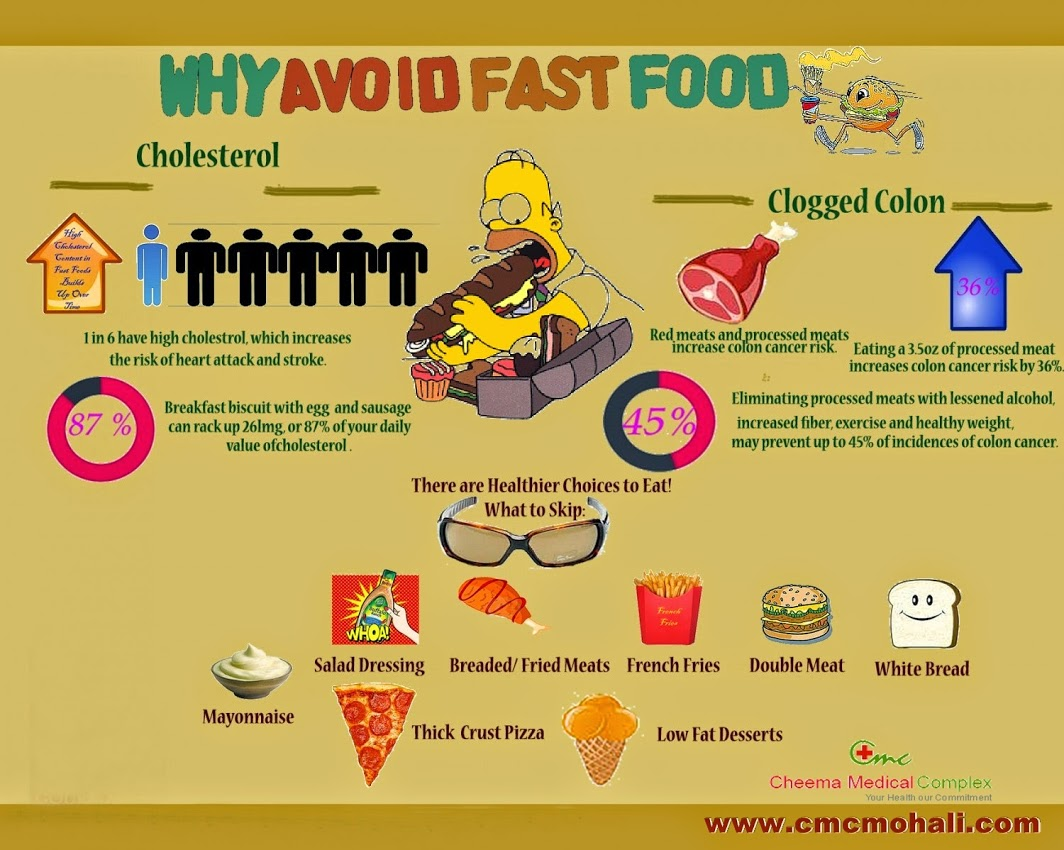What are the benefits of avoiding high cholesterol foods? Avoiding high cholesterol foods can have numerous health benefits. It may lower the risk of heart attack, stroke, and other cardiovascular diseases. According to the infographic, 1 in 6 individuals has high cholesterol, which significantly increases these risks. Reducing cholesterol intake can help maintain a healthy heart, reduce the risk of atherosclerosis, and improve overall health. What kinds of foods should I avoid to lower my cholesterol based on the infographic? The infographic suggests avoiding foods high in cholesterol, such as breakfast biscuits with egg and sausage, which can contribute 87% of the daily value of cholesterol. Specifically, it recommends skipping mayonnaise, salad dressing, breaded/fried meats, French fries, double meat burgers, white bread, thick crust pizza, and low-fat desserts. How can increasing fiber intake help in preventing colon cancer? Increasing fiber intake can play a significant role in preventing colon cancer. Fiber promotes healthy bowel movements and helps maintain the health of the digestive tract. By adding bulk to the stool and speeding up the passage of food through the intestines, fiber helps reduce the time that potential carcinogens stay in contact with the colon lining. Furthermore, a high-fiber diet typically includes more fruits, vegetables, and whole grains, which are rich in essential nutrients and antioxidants that support overall health and potentially reduce the risk of cancer. 